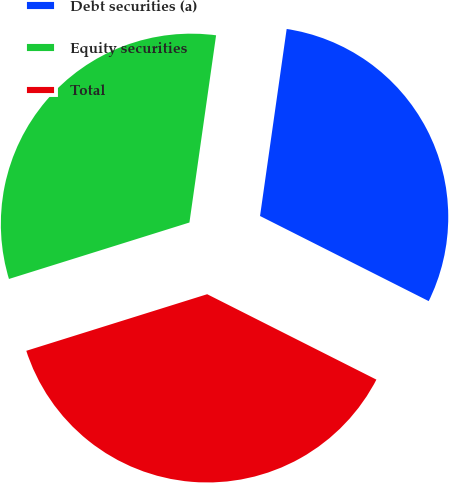<chart> <loc_0><loc_0><loc_500><loc_500><pie_chart><fcel>Debt securities (a)<fcel>Equity securities<fcel>Total<nl><fcel>30.19%<fcel>32.08%<fcel>37.74%<nl></chart> 